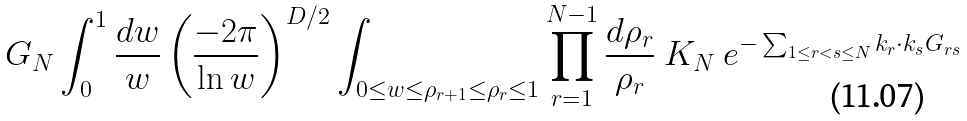Convert formula to latex. <formula><loc_0><loc_0><loc_500><loc_500>G _ { N } \int _ { 0 } ^ { 1 } \frac { d w } { w } \left ( \frac { - 2 \pi } { \ln w } \right ) ^ { D / 2 } \int _ { 0 \leq w \leq \rho _ { r + 1 } \leq \rho _ { r } \leq 1 } \prod _ { r = 1 } ^ { N - 1 } \frac { d \rho _ { r } } { \rho _ { r } } \ K _ { N } \ e ^ { - \sum _ { 1 \leq r < s \leq N } k _ { r } \cdot k _ { s } G _ { r s } }</formula> 